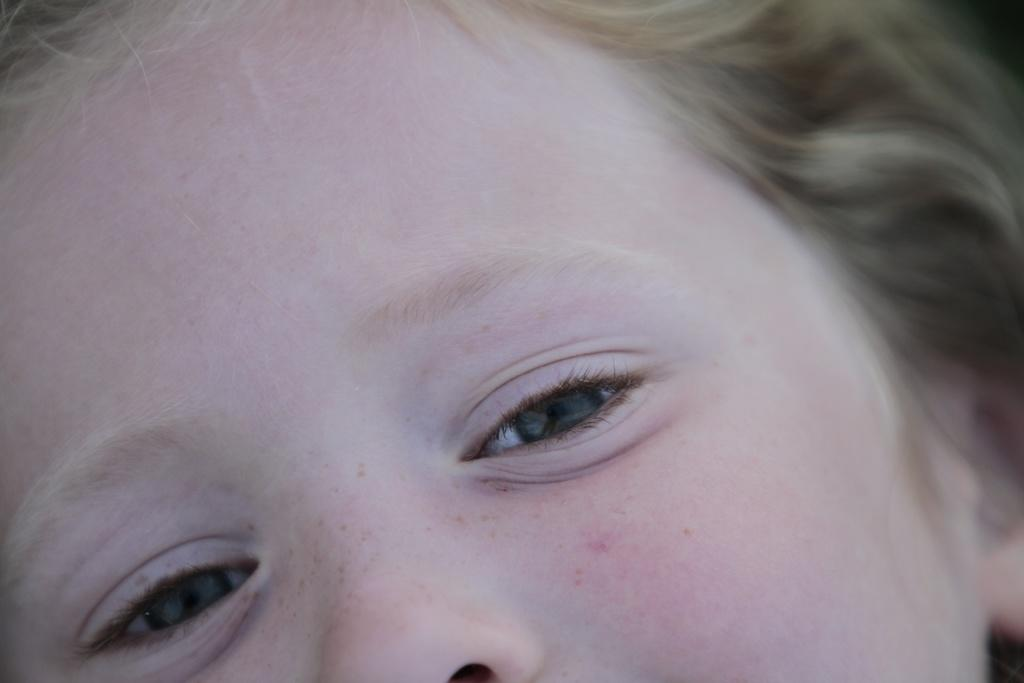What is the main subject of the picture? The main subject of the picture is a child's face. What facial features are visible in the image? The child's eyes and one nostril are visible in the image. What is the color of the child's hair? The child has gray color hair. What type of market can be seen in the background of the image? There is no market visible in the image; it features a child's face. Is there a band playing in the image? There is no band present in the image; it features a child's face. 